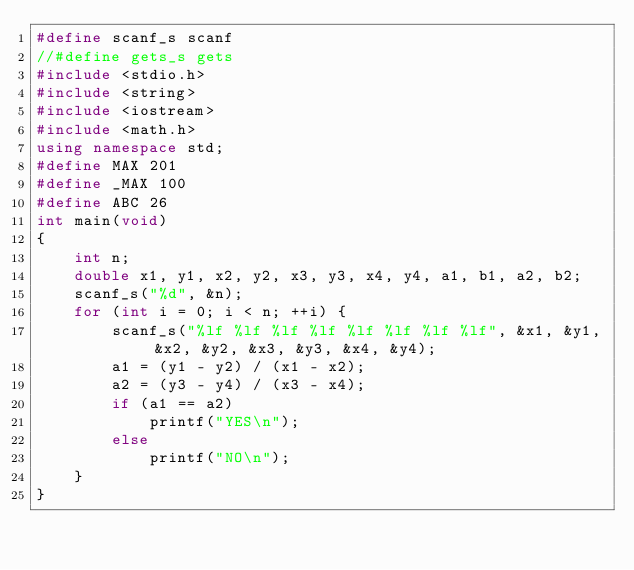<code> <loc_0><loc_0><loc_500><loc_500><_C++_>#define scanf_s scanf
//#define gets_s gets
#include <stdio.h>
#include <string>
#include <iostream>
#include <math.h>
using namespace std;
#define MAX 201
#define _MAX 100
#define ABC 26
int main(void)
{
	int n;
	double x1, y1, x2, y2, x3, y3, x4, y4, a1, b1, a2, b2;
	scanf_s("%d", &n);
	for (int i = 0; i < n; ++i) {
		scanf_s("%lf %lf %lf %lf %lf %lf %lf %lf", &x1, &y1, &x2, &y2, &x3, &y3, &x4, &y4);
		a1 = (y1 - y2) / (x1 - x2);
		a2 = (y3 - y4) / (x3 - x4);
		if (a1 == a2)
			printf("YES\n");
		else
			printf("NO\n");
	}
}</code> 